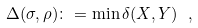Convert formula to latex. <formula><loc_0><loc_0><loc_500><loc_500>\Delta ( \sigma , \rho ) \colon = \min \delta ( X , Y ) \ ,</formula> 